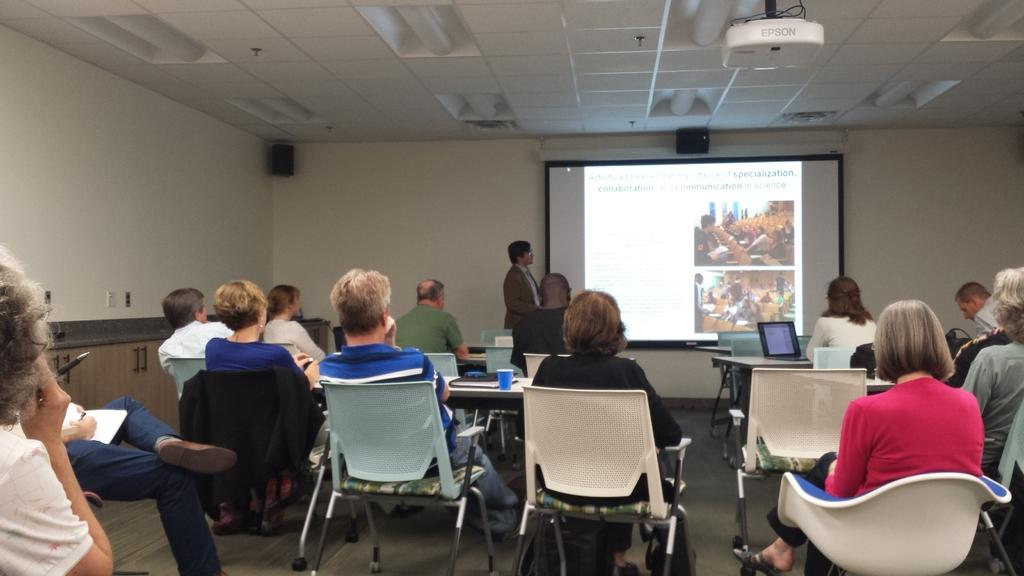What type of surface is visible in the image? There is a white wall in the image. What device is present in the image for displaying content? There is a screen in the image. What is used to project content onto the screen? There is a projector in the image. How are people positioned in the image? There are people sitting on chairs in the image. What type of furniture is present in the image? There are tables in the image. What electronic device is on one of the tables? There is a laptop on a table in the image. What other object is on a table in the image? There is a glass on a table in the image. Where is the office located in the image? There is no office present in the image. What type of doll is sitting on the chair in the image? There are no dolls present in the image. How many balloons are floating in the air in the image? There are no balloons present in the image. 